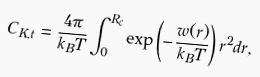Convert formula to latex. <formula><loc_0><loc_0><loc_500><loc_500>C _ { K , t } = \frac { 4 \pi } { k _ { B } T } \int _ { 0 } ^ { R _ { c } } \exp \left ( - \frac { w ( r ) } { k _ { B } T } \right ) r ^ { 2 } d r ,</formula> 